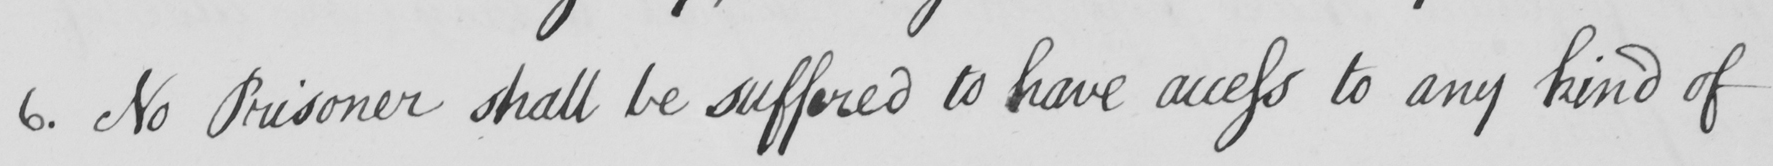Please provide the text content of this handwritten line. 6 . No Prisoner shall be suffered to have access to any kind of 